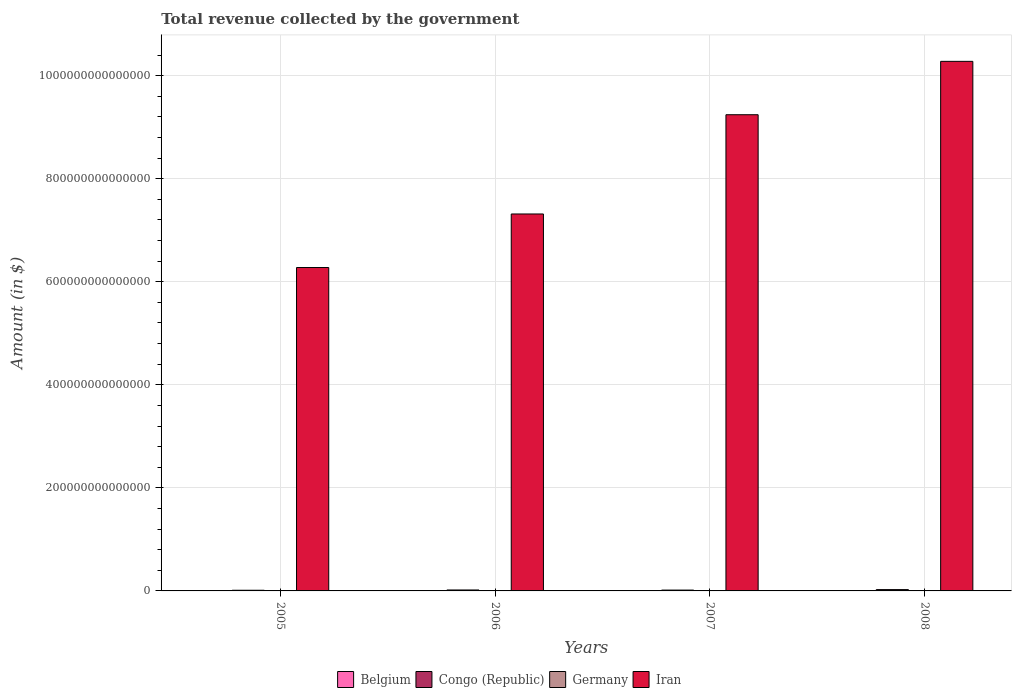Are the number of bars per tick equal to the number of legend labels?
Provide a short and direct response. Yes. How many bars are there on the 4th tick from the right?
Ensure brevity in your answer.  4. In how many cases, is the number of bars for a given year not equal to the number of legend labels?
Make the answer very short. 0. What is the total revenue collected by the government in Iran in 2008?
Ensure brevity in your answer.  1.03e+15. Across all years, what is the maximum total revenue collected by the government in Germany?
Offer a terse response. 6.99e+11. Across all years, what is the minimum total revenue collected by the government in Congo (Republic)?
Keep it short and to the point. 1.28e+12. In which year was the total revenue collected by the government in Iran maximum?
Offer a terse response. 2008. In which year was the total revenue collected by the government in Germany minimum?
Your answer should be very brief. 2005. What is the total total revenue collected by the government in Congo (Republic) in the graph?
Make the answer very short. 7.32e+12. What is the difference between the total revenue collected by the government in Iran in 2005 and that in 2006?
Give a very brief answer. -1.04e+14. What is the difference between the total revenue collected by the government in Belgium in 2007 and the total revenue collected by the government in Iran in 2006?
Your answer should be compact. -7.31e+14. What is the average total revenue collected by the government in Germany per year?
Offer a very short reply. 6.69e+11. In the year 2005, what is the difference between the total revenue collected by the government in Congo (Republic) and total revenue collected by the government in Belgium?
Your answer should be compact. 1.16e+12. What is the ratio of the total revenue collected by the government in Congo (Republic) in 2006 to that in 2007?
Ensure brevity in your answer.  1.13. Is the total revenue collected by the government in Congo (Republic) in 2005 less than that in 2007?
Provide a succinct answer. Yes. Is the difference between the total revenue collected by the government in Congo (Republic) in 2007 and 2008 greater than the difference between the total revenue collected by the government in Belgium in 2007 and 2008?
Offer a terse response. No. What is the difference between the highest and the second highest total revenue collected by the government in Belgium?
Give a very brief answer. 7.08e+09. What is the difference between the highest and the lowest total revenue collected by the government in Belgium?
Provide a short and direct response. 1.61e+1. Is it the case that in every year, the sum of the total revenue collected by the government in Belgium and total revenue collected by the government in Iran is greater than the sum of total revenue collected by the government in Congo (Republic) and total revenue collected by the government in Germany?
Your response must be concise. Yes. Are all the bars in the graph horizontal?
Offer a terse response. No. What is the difference between two consecutive major ticks on the Y-axis?
Provide a succinct answer. 2.00e+14. Are the values on the major ticks of Y-axis written in scientific E-notation?
Offer a very short reply. No. Does the graph contain grids?
Give a very brief answer. Yes. Where does the legend appear in the graph?
Your response must be concise. Bottom center. How many legend labels are there?
Your response must be concise. 4. How are the legend labels stacked?
Make the answer very short. Horizontal. What is the title of the graph?
Offer a very short reply. Total revenue collected by the government. Does "United Arab Emirates" appear as one of the legend labels in the graph?
Your answer should be very brief. No. What is the label or title of the X-axis?
Offer a terse response. Years. What is the label or title of the Y-axis?
Offer a very short reply. Amount (in $). What is the Amount (in $) of Belgium in 2005?
Give a very brief answer. 1.26e+11. What is the Amount (in $) of Congo (Republic) in 2005?
Your response must be concise. 1.28e+12. What is the Amount (in $) in Germany in 2005?
Your answer should be very brief. 6.37e+11. What is the Amount (in $) in Iran in 2005?
Provide a short and direct response. 6.28e+14. What is the Amount (in $) in Belgium in 2006?
Your response must be concise. 1.30e+11. What is the Amount (in $) in Congo (Republic) in 2006?
Offer a very short reply. 1.85e+12. What is the Amount (in $) in Germany in 2006?
Offer a very short reply. 6.58e+11. What is the Amount (in $) of Iran in 2006?
Provide a short and direct response. 7.32e+14. What is the Amount (in $) in Belgium in 2007?
Provide a succinct answer. 1.35e+11. What is the Amount (in $) of Congo (Republic) in 2007?
Your answer should be compact. 1.63e+12. What is the Amount (in $) of Germany in 2007?
Give a very brief answer. 6.83e+11. What is the Amount (in $) in Iran in 2007?
Make the answer very short. 9.24e+14. What is the Amount (in $) in Belgium in 2008?
Your response must be concise. 1.42e+11. What is the Amount (in $) of Congo (Republic) in 2008?
Ensure brevity in your answer.  2.56e+12. What is the Amount (in $) in Germany in 2008?
Ensure brevity in your answer.  6.99e+11. What is the Amount (in $) of Iran in 2008?
Your answer should be compact. 1.03e+15. Across all years, what is the maximum Amount (in $) in Belgium?
Your answer should be very brief. 1.42e+11. Across all years, what is the maximum Amount (in $) in Congo (Republic)?
Ensure brevity in your answer.  2.56e+12. Across all years, what is the maximum Amount (in $) in Germany?
Ensure brevity in your answer.  6.99e+11. Across all years, what is the maximum Amount (in $) of Iran?
Your answer should be very brief. 1.03e+15. Across all years, what is the minimum Amount (in $) of Belgium?
Make the answer very short. 1.26e+11. Across all years, what is the minimum Amount (in $) in Congo (Republic)?
Ensure brevity in your answer.  1.28e+12. Across all years, what is the minimum Amount (in $) of Germany?
Keep it short and to the point. 6.37e+11. Across all years, what is the minimum Amount (in $) in Iran?
Keep it short and to the point. 6.28e+14. What is the total Amount (in $) of Belgium in the graph?
Give a very brief answer. 5.32e+11. What is the total Amount (in $) in Congo (Republic) in the graph?
Provide a succinct answer. 7.32e+12. What is the total Amount (in $) in Germany in the graph?
Your answer should be compact. 2.68e+12. What is the total Amount (in $) of Iran in the graph?
Provide a short and direct response. 3.31e+15. What is the difference between the Amount (in $) of Belgium in 2005 and that in 2006?
Give a very brief answer. -4.14e+09. What is the difference between the Amount (in $) in Congo (Republic) in 2005 and that in 2006?
Provide a short and direct response. -5.64e+11. What is the difference between the Amount (in $) in Germany in 2005 and that in 2006?
Offer a terse response. -2.10e+1. What is the difference between the Amount (in $) of Iran in 2005 and that in 2006?
Give a very brief answer. -1.04e+14. What is the difference between the Amount (in $) of Belgium in 2005 and that in 2007?
Make the answer very short. -9.03e+09. What is the difference between the Amount (in $) in Congo (Republic) in 2005 and that in 2007?
Your answer should be very brief. -3.51e+11. What is the difference between the Amount (in $) in Germany in 2005 and that in 2007?
Provide a short and direct response. -4.54e+1. What is the difference between the Amount (in $) of Iran in 2005 and that in 2007?
Your answer should be very brief. -2.97e+14. What is the difference between the Amount (in $) of Belgium in 2005 and that in 2008?
Ensure brevity in your answer.  -1.61e+1. What is the difference between the Amount (in $) of Congo (Republic) in 2005 and that in 2008?
Give a very brief answer. -1.28e+12. What is the difference between the Amount (in $) of Germany in 2005 and that in 2008?
Your response must be concise. -6.20e+1. What is the difference between the Amount (in $) in Iran in 2005 and that in 2008?
Ensure brevity in your answer.  -4.00e+14. What is the difference between the Amount (in $) in Belgium in 2006 and that in 2007?
Offer a very short reply. -4.88e+09. What is the difference between the Amount (in $) of Congo (Republic) in 2006 and that in 2007?
Your answer should be compact. 2.12e+11. What is the difference between the Amount (in $) of Germany in 2006 and that in 2007?
Give a very brief answer. -2.44e+1. What is the difference between the Amount (in $) of Iran in 2006 and that in 2007?
Provide a succinct answer. -1.93e+14. What is the difference between the Amount (in $) of Belgium in 2006 and that in 2008?
Provide a succinct answer. -1.20e+1. What is the difference between the Amount (in $) in Congo (Republic) in 2006 and that in 2008?
Make the answer very short. -7.15e+11. What is the difference between the Amount (in $) in Germany in 2006 and that in 2008?
Your response must be concise. -4.10e+1. What is the difference between the Amount (in $) of Iran in 2006 and that in 2008?
Ensure brevity in your answer.  -2.96e+14. What is the difference between the Amount (in $) in Belgium in 2007 and that in 2008?
Ensure brevity in your answer.  -7.08e+09. What is the difference between the Amount (in $) in Congo (Republic) in 2007 and that in 2008?
Make the answer very short. -9.27e+11. What is the difference between the Amount (in $) of Germany in 2007 and that in 2008?
Provide a short and direct response. -1.66e+1. What is the difference between the Amount (in $) in Iran in 2007 and that in 2008?
Your answer should be compact. -1.04e+14. What is the difference between the Amount (in $) in Belgium in 2005 and the Amount (in $) in Congo (Republic) in 2006?
Offer a terse response. -1.72e+12. What is the difference between the Amount (in $) of Belgium in 2005 and the Amount (in $) of Germany in 2006?
Provide a short and direct response. -5.33e+11. What is the difference between the Amount (in $) of Belgium in 2005 and the Amount (in $) of Iran in 2006?
Offer a terse response. -7.31e+14. What is the difference between the Amount (in $) in Congo (Republic) in 2005 and the Amount (in $) in Germany in 2006?
Offer a terse response. 6.24e+11. What is the difference between the Amount (in $) of Congo (Republic) in 2005 and the Amount (in $) of Iran in 2006?
Your answer should be compact. -7.30e+14. What is the difference between the Amount (in $) of Germany in 2005 and the Amount (in $) of Iran in 2006?
Ensure brevity in your answer.  -7.31e+14. What is the difference between the Amount (in $) of Belgium in 2005 and the Amount (in $) of Congo (Republic) in 2007?
Your answer should be compact. -1.51e+12. What is the difference between the Amount (in $) in Belgium in 2005 and the Amount (in $) in Germany in 2007?
Provide a short and direct response. -5.57e+11. What is the difference between the Amount (in $) in Belgium in 2005 and the Amount (in $) in Iran in 2007?
Ensure brevity in your answer.  -9.24e+14. What is the difference between the Amount (in $) of Congo (Republic) in 2005 and the Amount (in $) of Germany in 2007?
Offer a terse response. 6.00e+11. What is the difference between the Amount (in $) of Congo (Republic) in 2005 and the Amount (in $) of Iran in 2007?
Give a very brief answer. -9.23e+14. What is the difference between the Amount (in $) in Germany in 2005 and the Amount (in $) in Iran in 2007?
Provide a succinct answer. -9.24e+14. What is the difference between the Amount (in $) of Belgium in 2005 and the Amount (in $) of Congo (Republic) in 2008?
Offer a terse response. -2.44e+12. What is the difference between the Amount (in $) of Belgium in 2005 and the Amount (in $) of Germany in 2008?
Ensure brevity in your answer.  -5.74e+11. What is the difference between the Amount (in $) in Belgium in 2005 and the Amount (in $) in Iran in 2008?
Ensure brevity in your answer.  -1.03e+15. What is the difference between the Amount (in $) of Congo (Republic) in 2005 and the Amount (in $) of Germany in 2008?
Ensure brevity in your answer.  5.83e+11. What is the difference between the Amount (in $) of Congo (Republic) in 2005 and the Amount (in $) of Iran in 2008?
Your response must be concise. -1.03e+15. What is the difference between the Amount (in $) in Germany in 2005 and the Amount (in $) in Iran in 2008?
Your response must be concise. -1.03e+15. What is the difference between the Amount (in $) in Belgium in 2006 and the Amount (in $) in Congo (Republic) in 2007?
Keep it short and to the point. -1.50e+12. What is the difference between the Amount (in $) of Belgium in 2006 and the Amount (in $) of Germany in 2007?
Give a very brief answer. -5.53e+11. What is the difference between the Amount (in $) in Belgium in 2006 and the Amount (in $) in Iran in 2007?
Give a very brief answer. -9.24e+14. What is the difference between the Amount (in $) in Congo (Republic) in 2006 and the Amount (in $) in Germany in 2007?
Keep it short and to the point. 1.16e+12. What is the difference between the Amount (in $) of Congo (Republic) in 2006 and the Amount (in $) of Iran in 2007?
Provide a short and direct response. -9.22e+14. What is the difference between the Amount (in $) in Germany in 2006 and the Amount (in $) in Iran in 2007?
Give a very brief answer. -9.24e+14. What is the difference between the Amount (in $) in Belgium in 2006 and the Amount (in $) in Congo (Republic) in 2008?
Make the answer very short. -2.43e+12. What is the difference between the Amount (in $) of Belgium in 2006 and the Amount (in $) of Germany in 2008?
Provide a short and direct response. -5.69e+11. What is the difference between the Amount (in $) in Belgium in 2006 and the Amount (in $) in Iran in 2008?
Keep it short and to the point. -1.03e+15. What is the difference between the Amount (in $) of Congo (Republic) in 2006 and the Amount (in $) of Germany in 2008?
Offer a very short reply. 1.15e+12. What is the difference between the Amount (in $) of Congo (Republic) in 2006 and the Amount (in $) of Iran in 2008?
Ensure brevity in your answer.  -1.03e+15. What is the difference between the Amount (in $) of Germany in 2006 and the Amount (in $) of Iran in 2008?
Give a very brief answer. -1.03e+15. What is the difference between the Amount (in $) in Belgium in 2007 and the Amount (in $) in Congo (Republic) in 2008?
Your answer should be compact. -2.43e+12. What is the difference between the Amount (in $) in Belgium in 2007 and the Amount (in $) in Germany in 2008?
Your response must be concise. -5.65e+11. What is the difference between the Amount (in $) in Belgium in 2007 and the Amount (in $) in Iran in 2008?
Your answer should be compact. -1.03e+15. What is the difference between the Amount (in $) of Congo (Republic) in 2007 and the Amount (in $) of Germany in 2008?
Make the answer very short. 9.34e+11. What is the difference between the Amount (in $) in Congo (Republic) in 2007 and the Amount (in $) in Iran in 2008?
Give a very brief answer. -1.03e+15. What is the difference between the Amount (in $) in Germany in 2007 and the Amount (in $) in Iran in 2008?
Make the answer very short. -1.03e+15. What is the average Amount (in $) in Belgium per year?
Keep it short and to the point. 1.33e+11. What is the average Amount (in $) in Congo (Republic) per year?
Your response must be concise. 1.83e+12. What is the average Amount (in $) in Germany per year?
Keep it short and to the point. 6.69e+11. What is the average Amount (in $) in Iran per year?
Offer a very short reply. 8.28e+14. In the year 2005, what is the difference between the Amount (in $) of Belgium and Amount (in $) of Congo (Republic)?
Provide a succinct answer. -1.16e+12. In the year 2005, what is the difference between the Amount (in $) of Belgium and Amount (in $) of Germany?
Ensure brevity in your answer.  -5.12e+11. In the year 2005, what is the difference between the Amount (in $) in Belgium and Amount (in $) in Iran?
Provide a short and direct response. -6.28e+14. In the year 2005, what is the difference between the Amount (in $) of Congo (Republic) and Amount (in $) of Germany?
Ensure brevity in your answer.  6.45e+11. In the year 2005, what is the difference between the Amount (in $) of Congo (Republic) and Amount (in $) of Iran?
Provide a succinct answer. -6.26e+14. In the year 2005, what is the difference between the Amount (in $) of Germany and Amount (in $) of Iran?
Provide a short and direct response. -6.27e+14. In the year 2006, what is the difference between the Amount (in $) of Belgium and Amount (in $) of Congo (Republic)?
Ensure brevity in your answer.  -1.72e+12. In the year 2006, what is the difference between the Amount (in $) in Belgium and Amount (in $) in Germany?
Your answer should be compact. -5.28e+11. In the year 2006, what is the difference between the Amount (in $) of Belgium and Amount (in $) of Iran?
Offer a terse response. -7.31e+14. In the year 2006, what is the difference between the Amount (in $) in Congo (Republic) and Amount (in $) in Germany?
Your answer should be compact. 1.19e+12. In the year 2006, what is the difference between the Amount (in $) in Congo (Republic) and Amount (in $) in Iran?
Ensure brevity in your answer.  -7.30e+14. In the year 2006, what is the difference between the Amount (in $) in Germany and Amount (in $) in Iran?
Ensure brevity in your answer.  -7.31e+14. In the year 2007, what is the difference between the Amount (in $) of Belgium and Amount (in $) of Congo (Republic)?
Give a very brief answer. -1.50e+12. In the year 2007, what is the difference between the Amount (in $) of Belgium and Amount (in $) of Germany?
Provide a succinct answer. -5.48e+11. In the year 2007, what is the difference between the Amount (in $) of Belgium and Amount (in $) of Iran?
Make the answer very short. -9.24e+14. In the year 2007, what is the difference between the Amount (in $) in Congo (Republic) and Amount (in $) in Germany?
Your answer should be very brief. 9.51e+11. In the year 2007, what is the difference between the Amount (in $) in Congo (Republic) and Amount (in $) in Iran?
Offer a very short reply. -9.23e+14. In the year 2007, what is the difference between the Amount (in $) of Germany and Amount (in $) of Iran?
Ensure brevity in your answer.  -9.24e+14. In the year 2008, what is the difference between the Amount (in $) of Belgium and Amount (in $) of Congo (Republic)?
Keep it short and to the point. -2.42e+12. In the year 2008, what is the difference between the Amount (in $) of Belgium and Amount (in $) of Germany?
Make the answer very short. -5.58e+11. In the year 2008, what is the difference between the Amount (in $) in Belgium and Amount (in $) in Iran?
Ensure brevity in your answer.  -1.03e+15. In the year 2008, what is the difference between the Amount (in $) in Congo (Republic) and Amount (in $) in Germany?
Your response must be concise. 1.86e+12. In the year 2008, what is the difference between the Amount (in $) of Congo (Republic) and Amount (in $) of Iran?
Offer a terse response. -1.03e+15. In the year 2008, what is the difference between the Amount (in $) of Germany and Amount (in $) of Iran?
Offer a very short reply. -1.03e+15. What is the ratio of the Amount (in $) in Belgium in 2005 to that in 2006?
Give a very brief answer. 0.97. What is the ratio of the Amount (in $) of Congo (Republic) in 2005 to that in 2006?
Offer a terse response. 0.69. What is the ratio of the Amount (in $) in Germany in 2005 to that in 2006?
Make the answer very short. 0.97. What is the ratio of the Amount (in $) of Iran in 2005 to that in 2006?
Keep it short and to the point. 0.86. What is the ratio of the Amount (in $) of Belgium in 2005 to that in 2007?
Offer a terse response. 0.93. What is the ratio of the Amount (in $) in Congo (Republic) in 2005 to that in 2007?
Offer a terse response. 0.78. What is the ratio of the Amount (in $) of Germany in 2005 to that in 2007?
Your answer should be very brief. 0.93. What is the ratio of the Amount (in $) of Iran in 2005 to that in 2007?
Provide a succinct answer. 0.68. What is the ratio of the Amount (in $) in Belgium in 2005 to that in 2008?
Offer a terse response. 0.89. What is the ratio of the Amount (in $) of Congo (Republic) in 2005 to that in 2008?
Make the answer very short. 0.5. What is the ratio of the Amount (in $) in Germany in 2005 to that in 2008?
Provide a succinct answer. 0.91. What is the ratio of the Amount (in $) of Iran in 2005 to that in 2008?
Your response must be concise. 0.61. What is the ratio of the Amount (in $) in Belgium in 2006 to that in 2007?
Provide a succinct answer. 0.96. What is the ratio of the Amount (in $) in Congo (Republic) in 2006 to that in 2007?
Offer a terse response. 1.13. What is the ratio of the Amount (in $) of Germany in 2006 to that in 2007?
Keep it short and to the point. 0.96. What is the ratio of the Amount (in $) in Iran in 2006 to that in 2007?
Make the answer very short. 0.79. What is the ratio of the Amount (in $) of Belgium in 2006 to that in 2008?
Make the answer very short. 0.92. What is the ratio of the Amount (in $) in Congo (Republic) in 2006 to that in 2008?
Give a very brief answer. 0.72. What is the ratio of the Amount (in $) in Germany in 2006 to that in 2008?
Keep it short and to the point. 0.94. What is the ratio of the Amount (in $) of Iran in 2006 to that in 2008?
Offer a very short reply. 0.71. What is the ratio of the Amount (in $) of Belgium in 2007 to that in 2008?
Keep it short and to the point. 0.95. What is the ratio of the Amount (in $) of Congo (Republic) in 2007 to that in 2008?
Keep it short and to the point. 0.64. What is the ratio of the Amount (in $) of Germany in 2007 to that in 2008?
Give a very brief answer. 0.98. What is the ratio of the Amount (in $) in Iran in 2007 to that in 2008?
Your response must be concise. 0.9. What is the difference between the highest and the second highest Amount (in $) in Belgium?
Your response must be concise. 7.08e+09. What is the difference between the highest and the second highest Amount (in $) of Congo (Republic)?
Provide a succinct answer. 7.15e+11. What is the difference between the highest and the second highest Amount (in $) in Germany?
Provide a succinct answer. 1.66e+1. What is the difference between the highest and the second highest Amount (in $) of Iran?
Offer a terse response. 1.04e+14. What is the difference between the highest and the lowest Amount (in $) of Belgium?
Ensure brevity in your answer.  1.61e+1. What is the difference between the highest and the lowest Amount (in $) in Congo (Republic)?
Make the answer very short. 1.28e+12. What is the difference between the highest and the lowest Amount (in $) in Germany?
Give a very brief answer. 6.20e+1. What is the difference between the highest and the lowest Amount (in $) of Iran?
Your response must be concise. 4.00e+14. 